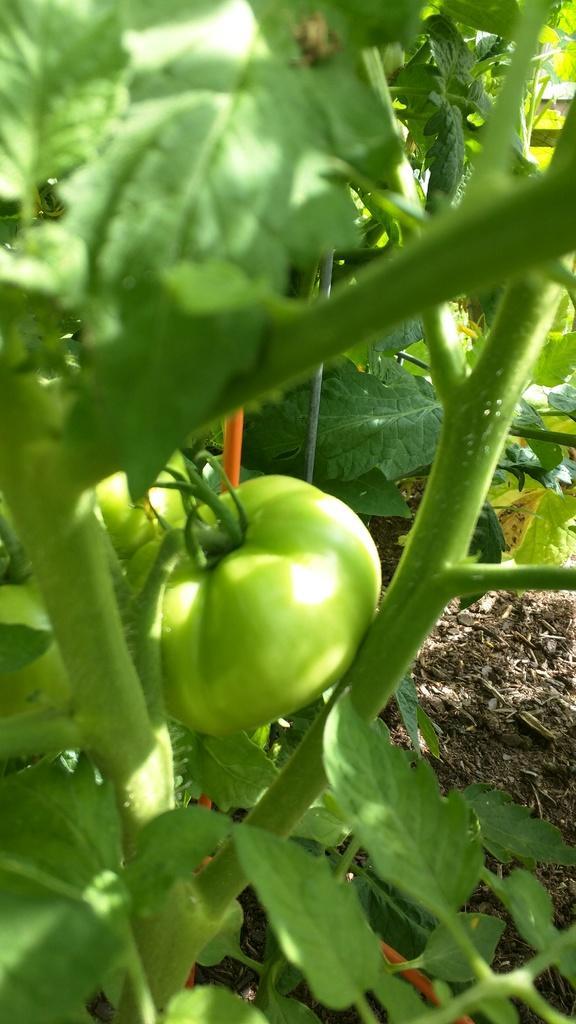Please provide a concise description of this image. In this image we can see a green color tomato, stems and leaves. 